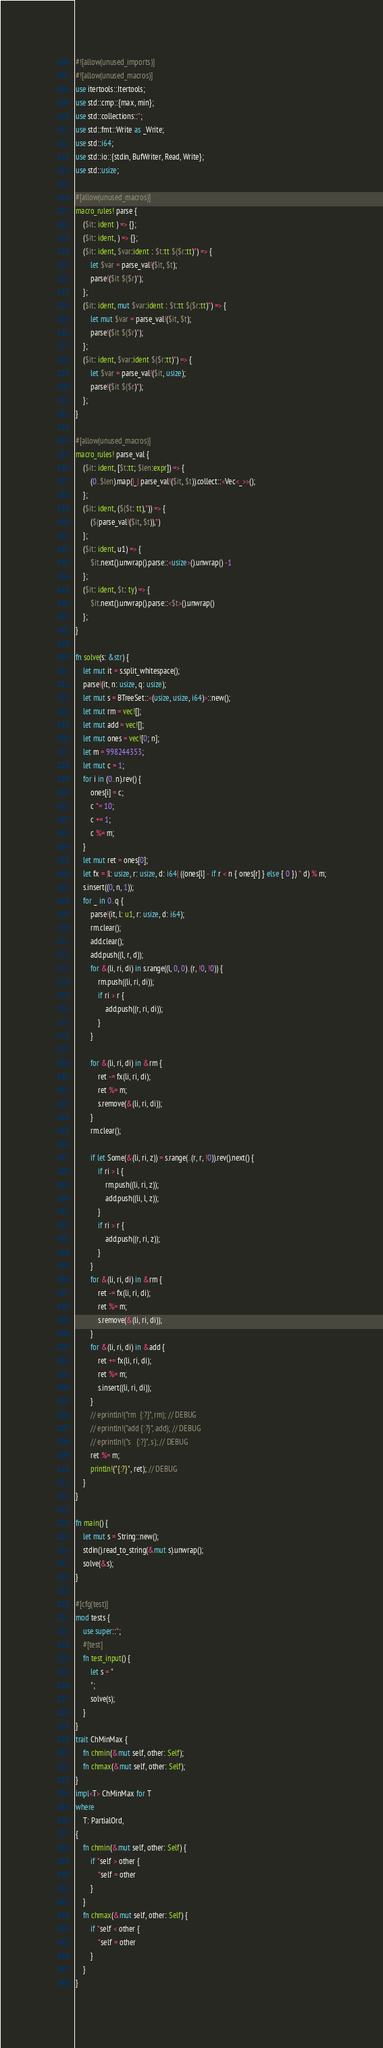Convert code to text. <code><loc_0><loc_0><loc_500><loc_500><_Rust_>#![allow(unused_imports)]
#![allow(unused_macros)]
use itertools::Itertools;
use std::cmp::{max, min};
use std::collections::*;
use std::fmt::Write as _Write;
use std::i64;
use std::io::{stdin, BufWriter, Read, Write};
use std::usize;

#[allow(unused_macros)]
macro_rules! parse {
    ($it: ident ) => {};
    ($it: ident, ) => {};
    ($it: ident, $var:ident : $t:tt $($r:tt)*) => {
        let $var = parse_val!($it, $t);
        parse!($it $($r)*);
    };
    ($it: ident, mut $var:ident : $t:tt $($r:tt)*) => {
        let mut $var = parse_val!($it, $t);
        parse!($it $($r)*);
    };
    ($it: ident, $var:ident $($r:tt)*) => {
        let $var = parse_val!($it, usize);
        parse!($it $($r)*);
    };
}

#[allow(unused_macros)]
macro_rules! parse_val {
    ($it: ident, [$t:tt; $len:expr]) => {
        (0..$len).map(|_| parse_val!($it, $t)).collect::<Vec<_>>();
    };
    ($it: ident, ($($t: tt),*)) => {
        ($(parse_val!($it, $t)),*)
    };
    ($it: ident, u1) => {
        $it.next().unwrap().parse::<usize>().unwrap() -1
    };
    ($it: ident, $t: ty) => {
        $it.next().unwrap().parse::<$t>().unwrap()
    };
}

fn solve(s: &str) {
    let mut it = s.split_whitespace();
    parse!(it, n: usize, q: usize);
    let mut s = BTreeSet::<(usize, usize, i64)>::new();
    let mut rm = vec![];
    let mut add = vec![];
    let mut ones = vec![0; n];
    let m = 998244353;
    let mut c = 1;
    for i in (0..n).rev() {
        ones[i] = c;
        c *= 10;
        c += 1;
        c %= m;
    }
    let mut ret = ones[0];
    let fx = |l: usize, r: usize, d: i64| ((ones[l] - if r < n { ones[r] } else { 0 }) * d) % m;
    s.insert((0, n, 1));
    for _ in 0..q {
        parse!(it, l: u1, r: usize, d: i64);
        rm.clear();
        add.clear();
        add.push((l, r, d));
        for &(li, ri, di) in s.range((l, 0, 0)..(r, !0, !0)) {
            rm.push((li, ri, di));
            if ri > r {
                add.push((r, ri, di));
            }
        }

        for &(li, ri, di) in &rm {
            ret -= fx(li, ri, di);
            ret %= m;
            s.remove(&(li, ri, di));
        }
        rm.clear();

        if let Some(&(li, ri, z)) = s.range(..(r, r, !0)).rev().next() {
            if ri > l {
                rm.push((li, ri, z));
                add.push((li, l, z));
            }
            if ri > r {
                add.push((r, ri, z));
            }
        }
        for &(li, ri, di) in &rm {
            ret -= fx(li, ri, di);
            ret %= m;
            s.remove(&(li, ri, di));
        }
        for &(li, ri, di) in &add {
            ret += fx(li, ri, di);
            ret %= m;
            s.insert((li, ri, di));
        }
        // eprintln!("rm  {:?}", rm); // DEBUG
        // eprintln!("add {:?}", add); // DEBUG
        // eprintln!("s   {:?}", s); // DEBUG
        ret %= m;
        println!("{:?}", ret); // DEBUG
    }
}

fn main() {
    let mut s = String::new();
    stdin().read_to_string(&mut s).unwrap();
    solve(&s);
}

#[cfg(test)]
mod tests {
    use super::*;
    #[test]
    fn test_input() {
        let s = "
        ";
        solve(s);
    }
}
trait ChMinMax {
    fn chmin(&mut self, other: Self);
    fn chmax(&mut self, other: Self);
}
impl<T> ChMinMax for T
where
    T: PartialOrd,
{
    fn chmin(&mut self, other: Self) {
        if *self > other {
            *self = other
        }
    }
    fn chmax(&mut self, other: Self) {
        if *self < other {
            *self = other
        }
    }
}
</code> 